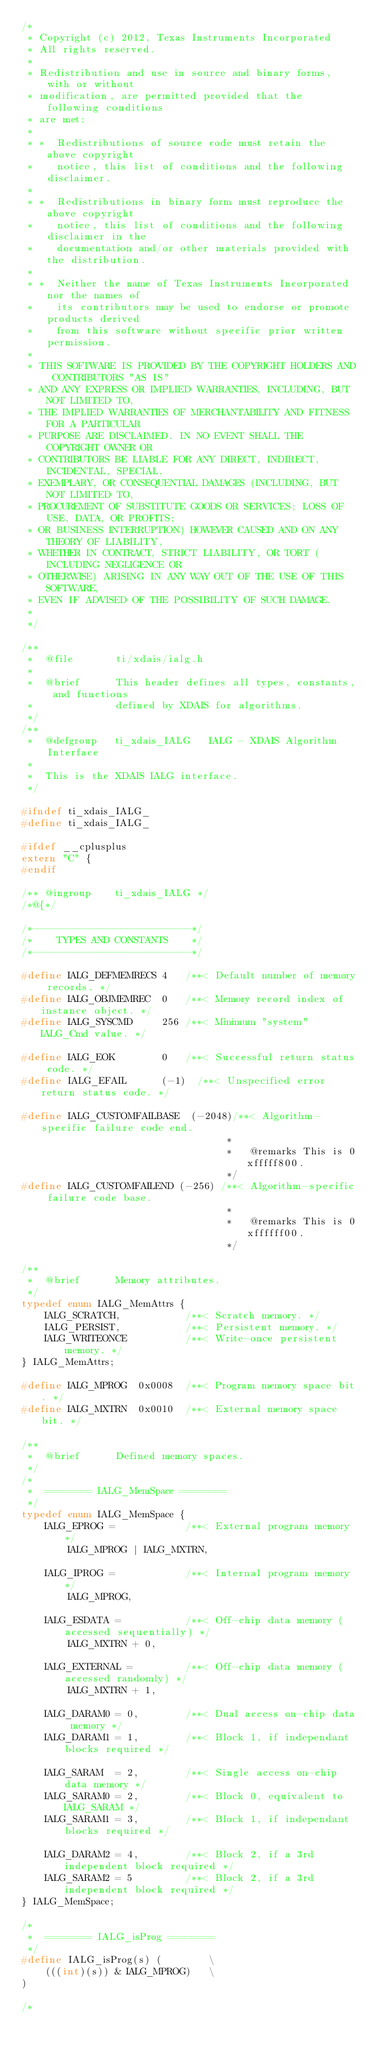Convert code to text. <code><loc_0><loc_0><loc_500><loc_500><_C_>/* 
 * Copyright (c) 2012, Texas Instruments Incorporated
 * All rights reserved.
 *
 * Redistribution and use in source and binary forms, with or without
 * modification, are permitted provided that the following conditions
 * are met:
 *
 * *  Redistributions of source code must retain the above copyright
 *    notice, this list of conditions and the following disclaimer.
 *
 * *  Redistributions in binary form must reproduce the above copyright
 *    notice, this list of conditions and the following disclaimer in the
 *    documentation and/or other materials provided with the distribution.
 *
 * *  Neither the name of Texas Instruments Incorporated nor the names of
 *    its contributors may be used to endorse or promote products derived
 *    from this software without specific prior written permission.
 *
 * THIS SOFTWARE IS PROVIDED BY THE COPYRIGHT HOLDERS AND CONTRIBUTORS "AS IS"
 * AND ANY EXPRESS OR IMPLIED WARRANTIES, INCLUDING, BUT NOT LIMITED TO,
 * THE IMPLIED WARRANTIES OF MERCHANTABILITY AND FITNESS FOR A PARTICULAR
 * PURPOSE ARE DISCLAIMED. IN NO EVENT SHALL THE COPYRIGHT OWNER OR
 * CONTRIBUTORS BE LIABLE FOR ANY DIRECT, INDIRECT, INCIDENTAL, SPECIAL,
 * EXEMPLARY, OR CONSEQUENTIAL DAMAGES (INCLUDING, BUT NOT LIMITED TO,
 * PROCUREMENT OF SUBSTITUTE GOODS OR SERVICES; LOSS OF USE, DATA, OR PROFITS;
 * OR BUSINESS INTERRUPTION) HOWEVER CAUSED AND ON ANY THEORY OF LIABILITY,
 * WHETHER IN CONTRACT, STRICT LIABILITY, OR TORT (INCLUDING NEGLIGENCE OR
 * OTHERWISE) ARISING IN ANY WAY OUT OF THE USE OF THIS SOFTWARE,
 * EVEN IF ADVISED OF THE POSSIBILITY OF SUCH DAMAGE.
 * 
 */

/**
 *  @file       ti/xdais/ialg.h
 *
 *  @brief      This header defines all types, constants, and functions
 *              defined by XDAIS for algorithms.
 */
/**
 *  @defgroup   ti_xdais_IALG   IALG - XDAIS Algorithm Interface
 *
 *  This is the XDAIS IALG interface.
 */

#ifndef ti_xdais_IALG_
#define ti_xdais_IALG_

#ifdef __cplusplus
extern "C" {
#endif

/** @ingroup    ti_xdais_IALG */
/*@{*/

/*---------------------------*/
/*    TYPES AND CONSTANTS    */
/*---------------------------*/

#define IALG_DEFMEMRECS 4   /**< Default number of memory records. */
#define IALG_OBJMEMREC  0   /**< Memory record index of instance object. */
#define IALG_SYSCMD     256 /**< Minimum "system" IALG_Cmd value. */

#define IALG_EOK        0   /**< Successful return status code. */
#define IALG_EFAIL      (-1)  /**< Unspecified error return status code. */

#define IALG_CUSTOMFAILBASE  (-2048)/**< Algorithm-specific failure code end.
                                   *
                                   *   @remarks This is 0xfffff800.
                                   */
#define IALG_CUSTOMFAILEND (-256) /**< Algorithm-specific failure code base.
                                   *
                                   *   @remarks This is 0xffffff00.
                                   */

/**
 *  @brief      Memory attributes.
 */
typedef enum IALG_MemAttrs {
    IALG_SCRATCH,           /**< Scratch memory. */
    IALG_PERSIST,           /**< Persistent memory. */
    IALG_WRITEONCE          /**< Write-once persistent memory. */
} IALG_MemAttrs;

#define IALG_MPROG  0x0008  /**< Program memory space bit. */
#define IALG_MXTRN  0x0010  /**< External memory space bit. */

/**
 *  @brief      Defined memory spaces.
 */
/*
 *  ======== IALG_MemSpace ========
 */
typedef enum IALG_MemSpace {
    IALG_EPROG =            /**< External program memory */
        IALG_MPROG | IALG_MXTRN,

    IALG_IPROG =            /**< Internal program memory */
        IALG_MPROG,

    IALG_ESDATA =           /**< Off-chip data memory (accessed sequentially) */
        IALG_MXTRN + 0,

    IALG_EXTERNAL =         /**< Off-chip data memory (accessed randomly) */
        IALG_MXTRN + 1,

    IALG_DARAM0 = 0,        /**< Dual access on-chip data memory */
    IALG_DARAM1 = 1,        /**< Block 1, if independant blocks required */

    IALG_SARAM  = 2,        /**< Single access on-chip data memory */
    IALG_SARAM0 = 2,        /**< Block 0, equivalent to IALG_SARAM */
    IALG_SARAM1 = 3,        /**< Block 1, if independant blocks required */

    IALG_DARAM2 = 4,        /**< Block 2, if a 3rd independent block required */
    IALG_SARAM2 = 5         /**< Block 2, if a 3rd independent block required */
} IALG_MemSpace;

/*
 *  ======== IALG_isProg ========
 */
#define IALG_isProg(s) (        \
    (((int)(s)) & IALG_MPROG)   \
)

/*</code> 